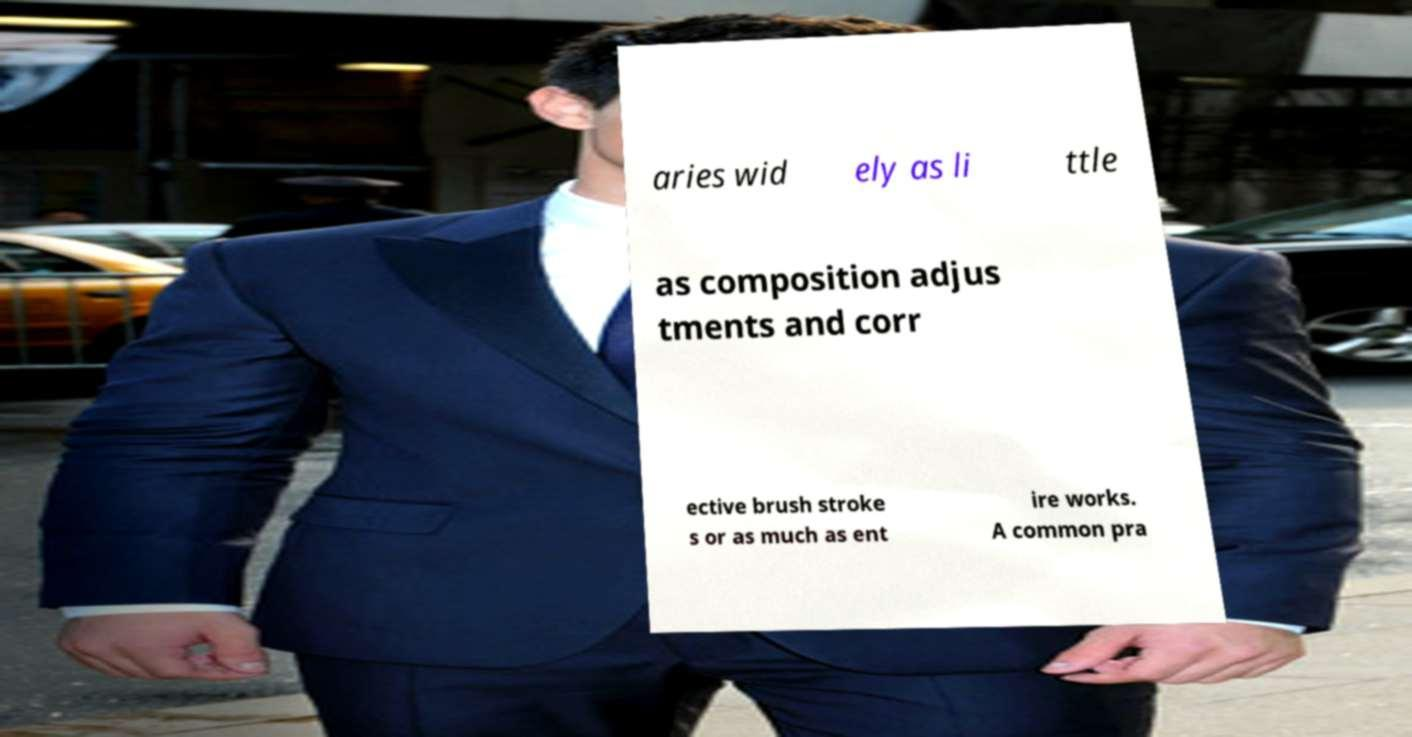Please identify and transcribe the text found in this image. aries wid ely as li ttle as composition adjus tments and corr ective brush stroke s or as much as ent ire works. A common pra 